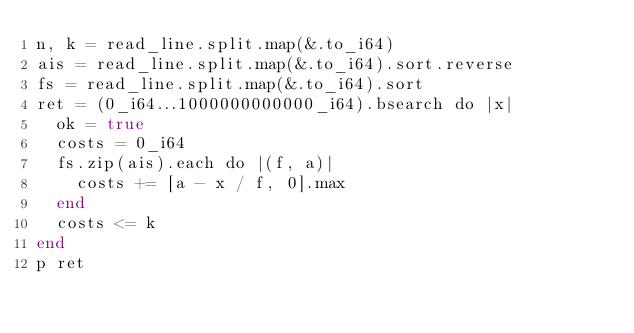Convert code to text. <code><loc_0><loc_0><loc_500><loc_500><_Crystal_>n, k = read_line.split.map(&.to_i64)
ais = read_line.split.map(&.to_i64).sort.reverse
fs = read_line.split.map(&.to_i64).sort
ret = (0_i64...1000000000000_i64).bsearch do |x|
  ok = true
  costs = 0_i64
  fs.zip(ais).each do |(f, a)|
    costs += [a - x / f, 0].max
  end
  costs <= k
end
p ret
</code> 